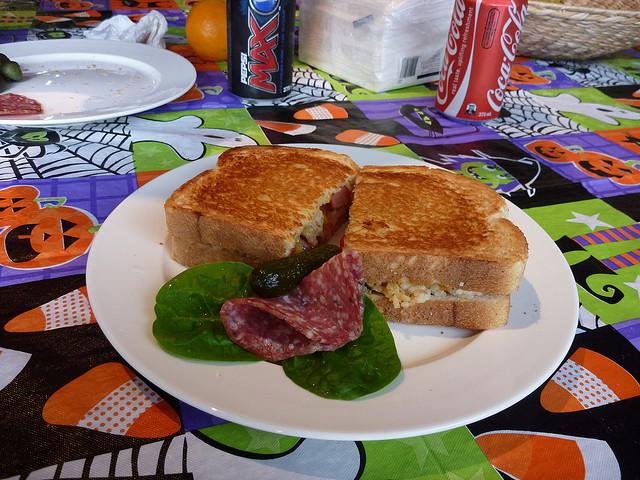What month most likely is it?
Concise answer only. October. Is the sandwich toasted?
Keep it brief. Yes. What is the brand of the red and white can?
Keep it brief. Coca cola. 